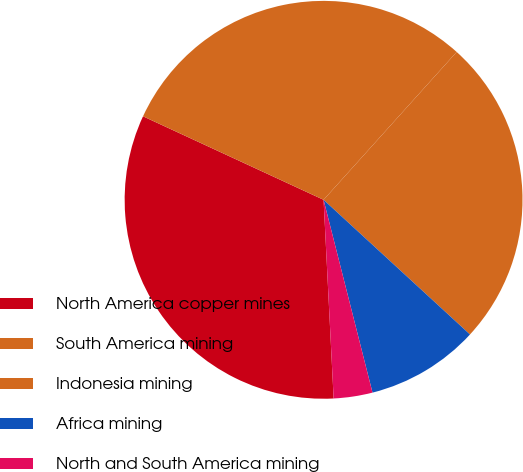Convert chart to OTSL. <chart><loc_0><loc_0><loc_500><loc_500><pie_chart><fcel>North America copper mines<fcel>South America mining<fcel>Indonesia mining<fcel>Africa mining<fcel>North and South America mining<nl><fcel>32.7%<fcel>29.77%<fcel>25.17%<fcel>9.21%<fcel>3.15%<nl></chart> 